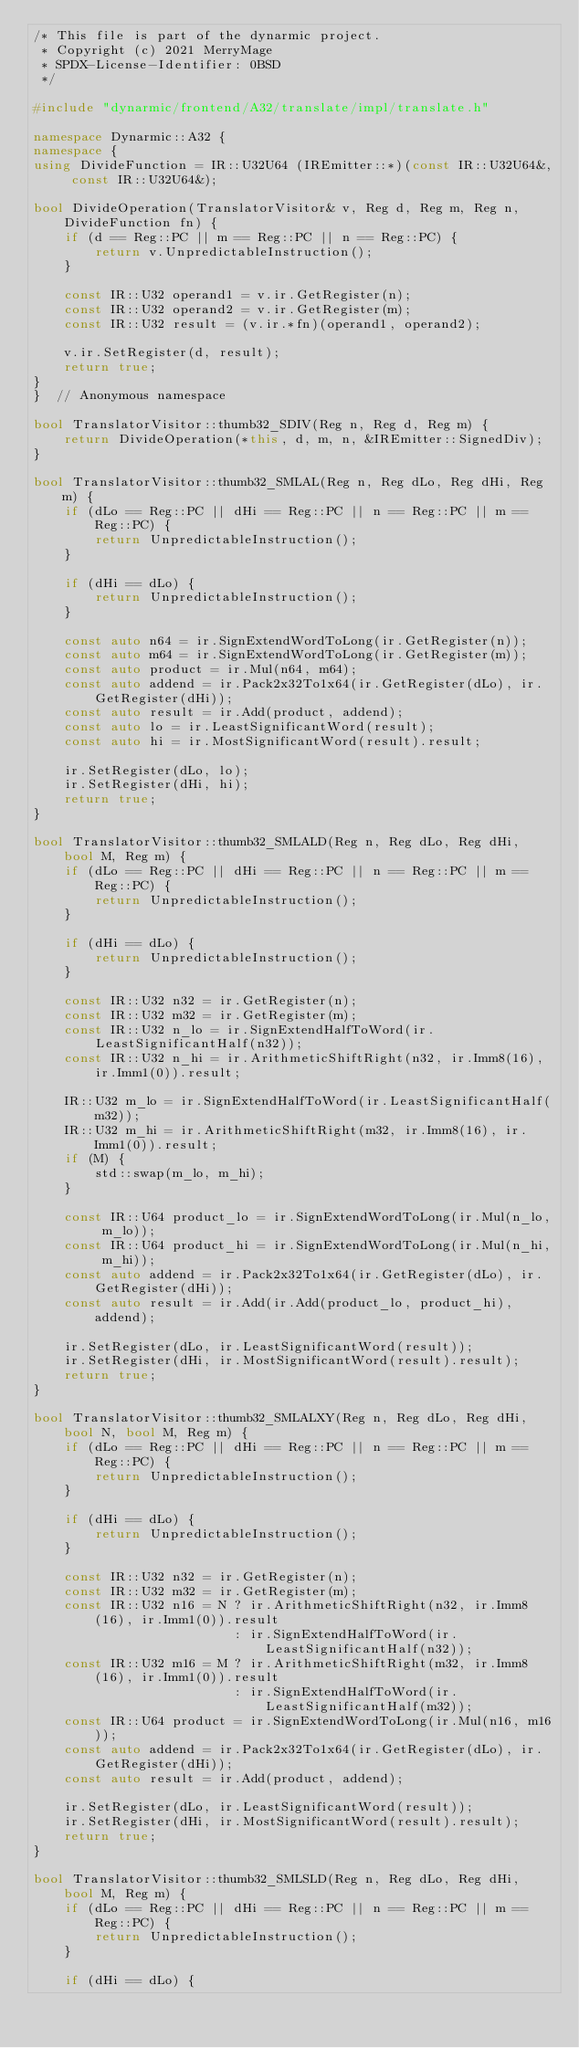<code> <loc_0><loc_0><loc_500><loc_500><_C++_>/* This file is part of the dynarmic project.
 * Copyright (c) 2021 MerryMage
 * SPDX-License-Identifier: 0BSD
 */

#include "dynarmic/frontend/A32/translate/impl/translate.h"

namespace Dynarmic::A32 {
namespace {
using DivideFunction = IR::U32U64 (IREmitter::*)(const IR::U32U64&, const IR::U32U64&);

bool DivideOperation(TranslatorVisitor& v, Reg d, Reg m, Reg n, DivideFunction fn) {
    if (d == Reg::PC || m == Reg::PC || n == Reg::PC) {
        return v.UnpredictableInstruction();
    }

    const IR::U32 operand1 = v.ir.GetRegister(n);
    const IR::U32 operand2 = v.ir.GetRegister(m);
    const IR::U32 result = (v.ir.*fn)(operand1, operand2);

    v.ir.SetRegister(d, result);
    return true;
}
}  // Anonymous namespace

bool TranslatorVisitor::thumb32_SDIV(Reg n, Reg d, Reg m) {
    return DivideOperation(*this, d, m, n, &IREmitter::SignedDiv);
}

bool TranslatorVisitor::thumb32_SMLAL(Reg n, Reg dLo, Reg dHi, Reg m) {
    if (dLo == Reg::PC || dHi == Reg::PC || n == Reg::PC || m == Reg::PC) {
        return UnpredictableInstruction();
    }

    if (dHi == dLo) {
        return UnpredictableInstruction();
    }

    const auto n64 = ir.SignExtendWordToLong(ir.GetRegister(n));
    const auto m64 = ir.SignExtendWordToLong(ir.GetRegister(m));
    const auto product = ir.Mul(n64, m64);
    const auto addend = ir.Pack2x32To1x64(ir.GetRegister(dLo), ir.GetRegister(dHi));
    const auto result = ir.Add(product, addend);
    const auto lo = ir.LeastSignificantWord(result);
    const auto hi = ir.MostSignificantWord(result).result;

    ir.SetRegister(dLo, lo);
    ir.SetRegister(dHi, hi);
    return true;
}

bool TranslatorVisitor::thumb32_SMLALD(Reg n, Reg dLo, Reg dHi, bool M, Reg m) {
    if (dLo == Reg::PC || dHi == Reg::PC || n == Reg::PC || m == Reg::PC) {
        return UnpredictableInstruction();
    }

    if (dHi == dLo) {
        return UnpredictableInstruction();
    }

    const IR::U32 n32 = ir.GetRegister(n);
    const IR::U32 m32 = ir.GetRegister(m);
    const IR::U32 n_lo = ir.SignExtendHalfToWord(ir.LeastSignificantHalf(n32));
    const IR::U32 n_hi = ir.ArithmeticShiftRight(n32, ir.Imm8(16), ir.Imm1(0)).result;

    IR::U32 m_lo = ir.SignExtendHalfToWord(ir.LeastSignificantHalf(m32));
    IR::U32 m_hi = ir.ArithmeticShiftRight(m32, ir.Imm8(16), ir.Imm1(0)).result;
    if (M) {
        std::swap(m_lo, m_hi);
    }

    const IR::U64 product_lo = ir.SignExtendWordToLong(ir.Mul(n_lo, m_lo));
    const IR::U64 product_hi = ir.SignExtendWordToLong(ir.Mul(n_hi, m_hi));
    const auto addend = ir.Pack2x32To1x64(ir.GetRegister(dLo), ir.GetRegister(dHi));
    const auto result = ir.Add(ir.Add(product_lo, product_hi), addend);

    ir.SetRegister(dLo, ir.LeastSignificantWord(result));
    ir.SetRegister(dHi, ir.MostSignificantWord(result).result);
    return true;
}

bool TranslatorVisitor::thumb32_SMLALXY(Reg n, Reg dLo, Reg dHi, bool N, bool M, Reg m) {
    if (dLo == Reg::PC || dHi == Reg::PC || n == Reg::PC || m == Reg::PC) {
        return UnpredictableInstruction();
    }

    if (dHi == dLo) {
        return UnpredictableInstruction();
    }

    const IR::U32 n32 = ir.GetRegister(n);
    const IR::U32 m32 = ir.GetRegister(m);
    const IR::U32 n16 = N ? ir.ArithmeticShiftRight(n32, ir.Imm8(16), ir.Imm1(0)).result
                          : ir.SignExtendHalfToWord(ir.LeastSignificantHalf(n32));
    const IR::U32 m16 = M ? ir.ArithmeticShiftRight(m32, ir.Imm8(16), ir.Imm1(0)).result
                          : ir.SignExtendHalfToWord(ir.LeastSignificantHalf(m32));
    const IR::U64 product = ir.SignExtendWordToLong(ir.Mul(n16, m16));
    const auto addend = ir.Pack2x32To1x64(ir.GetRegister(dLo), ir.GetRegister(dHi));
    const auto result = ir.Add(product, addend);

    ir.SetRegister(dLo, ir.LeastSignificantWord(result));
    ir.SetRegister(dHi, ir.MostSignificantWord(result).result);
    return true;
}

bool TranslatorVisitor::thumb32_SMLSLD(Reg n, Reg dLo, Reg dHi, bool M, Reg m) {
    if (dLo == Reg::PC || dHi == Reg::PC || n == Reg::PC || m == Reg::PC) {
        return UnpredictableInstruction();
    }

    if (dHi == dLo) {</code> 